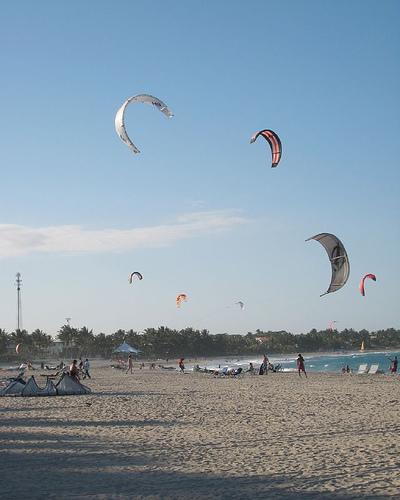What color is the highest kite?
Quick response, please. White. Where are the people flying kites?
Answer briefly. Beach. What is the location of the kites being flown?
Write a very short answer. Beach. How many kites can be seen?
Quick response, please. 7. 